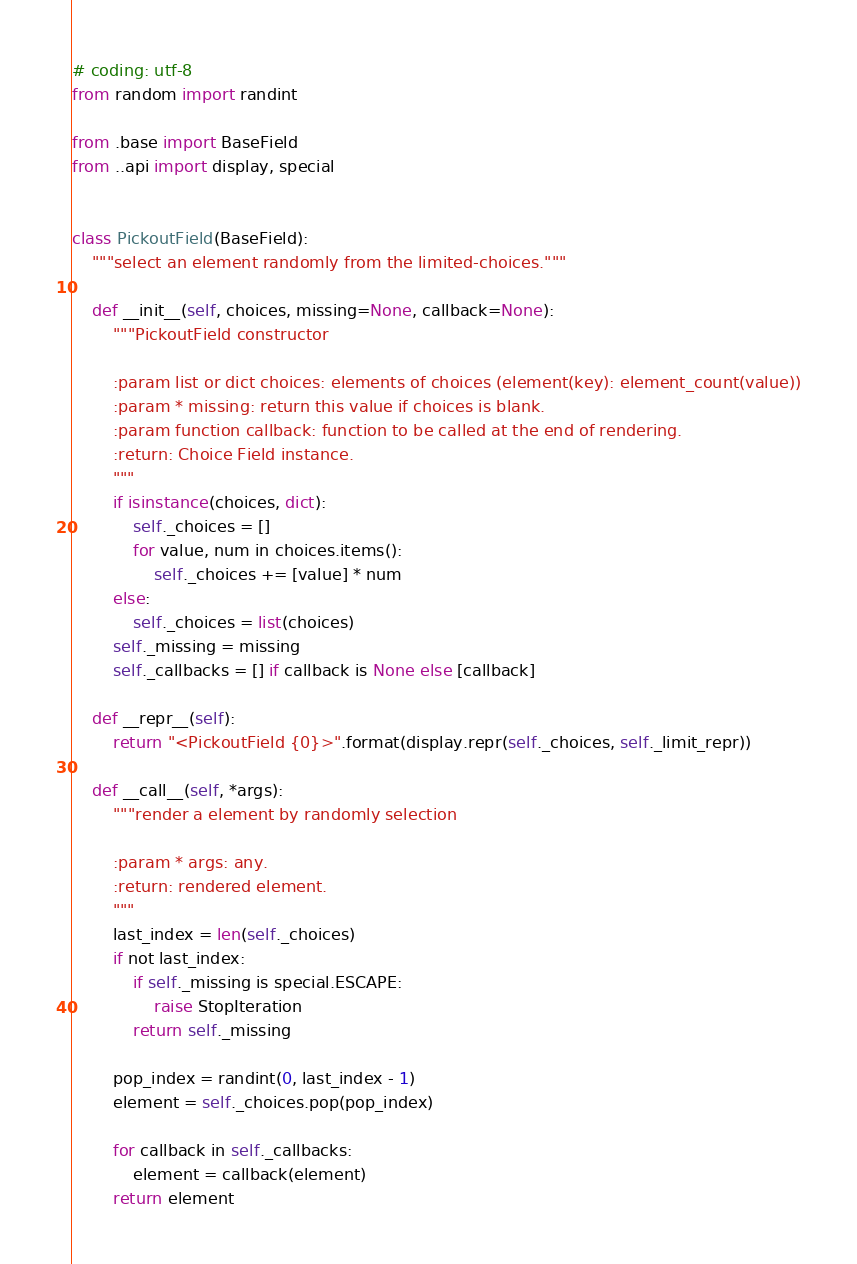Convert code to text. <code><loc_0><loc_0><loc_500><loc_500><_Python_># coding: utf-8
from random import randint

from .base import BaseField
from ..api import display, special


class PickoutField(BaseField):
    """select an element randomly from the limited-choices."""

    def __init__(self, choices, missing=None, callback=None):
        """PickoutField constructor

        :param list or dict choices: elements of choices (element(key): element_count(value))
        :param * missing: return this value if choices is blank.
        :param function callback: function to be called at the end of rendering.
        :return: Choice Field instance.
        """
        if isinstance(choices, dict):
            self._choices = []
            for value, num in choices.items():
                self._choices += [value] * num
        else:
            self._choices = list(choices)
        self._missing = missing
        self._callbacks = [] if callback is None else [callback]

    def __repr__(self):
        return "<PickoutField {0}>".format(display.repr(self._choices, self._limit_repr))

    def __call__(self, *args):
        """render a element by randomly selection

        :param * args: any.
        :return: rendered element.
        """
        last_index = len(self._choices)
        if not last_index:
            if self._missing is special.ESCAPE:
                raise StopIteration
            return self._missing

        pop_index = randint(0, last_index - 1)
        element = self._choices.pop(pop_index)

        for callback in self._callbacks:
            element = callback(element)
        return element
</code> 